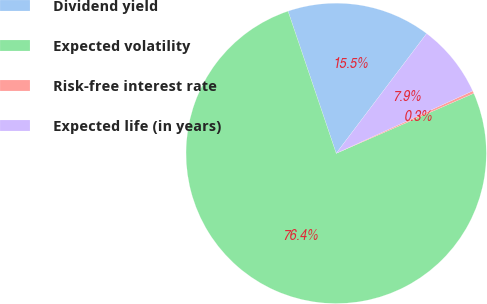<chart> <loc_0><loc_0><loc_500><loc_500><pie_chart><fcel>Dividend yield<fcel>Expected volatility<fcel>Risk-free interest rate<fcel>Expected life (in years)<nl><fcel>15.49%<fcel>76.35%<fcel>0.28%<fcel>7.88%<nl></chart> 